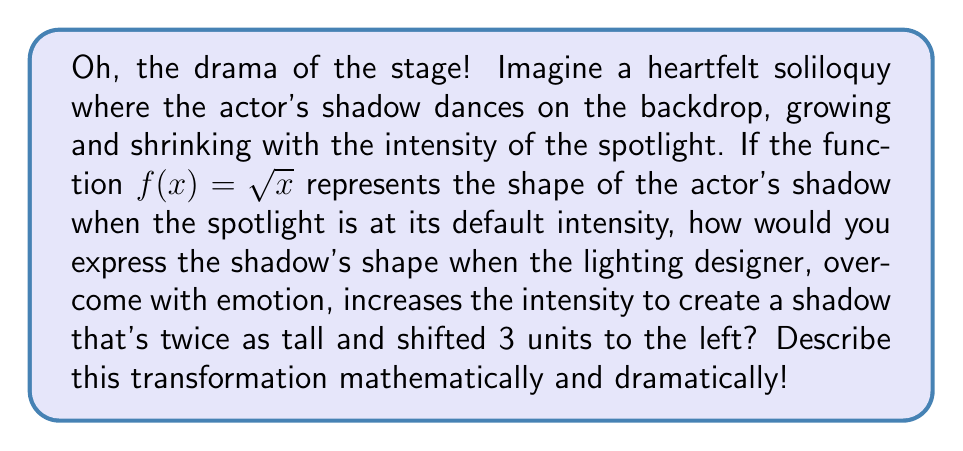Show me your answer to this math problem. Let's unravel this theatrical transformation with the passion it deserves!

1) Our original shadow is represented by $f(x) = \sqrt{x}$. This is our baseline, the raw, unaltered silhouette of our actor.

2) The lighting designer, in a fit of artistic fervor, decides to double the height of the shadow. This is a vertical stretch by a factor of 2. We can represent this as:

   $2f(x) = 2\sqrt{x}$

3) But wait! The drama intensifies! The shadow must also be shifted 3 units to the left. This is a horizontal shift, and it's represented by replacing x with (x + 3):

   $2f(x + 3) = 2\sqrt{x + 3}$

4) Thus, our final, transformed function is:

   $g(x) = 2\sqrt{x + 3}$

This new function, $g(x)$, captures all the heightened emotion and intensity of the scene. The shadow now looms twice as tall, creating a more imposing presence, while the leftward shift adds a sense of anticipation, as if the shadow is reaching out towards the audience.

Oh, the power of mathematical transformations to convey the depth of human emotion on stage!
Answer: $g(x) = 2\sqrt{x + 3}$ 